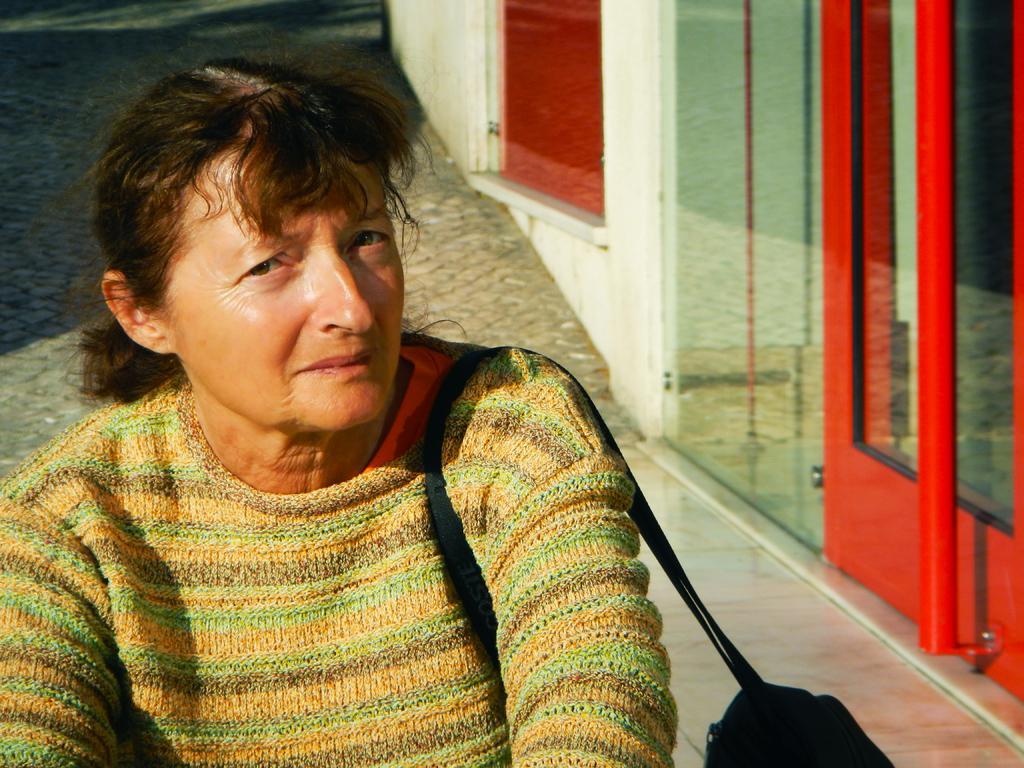Could you give a brief overview of what you see in this image? In the picture I can see a woman who is carrying a bag. In the background I can see some objects. 